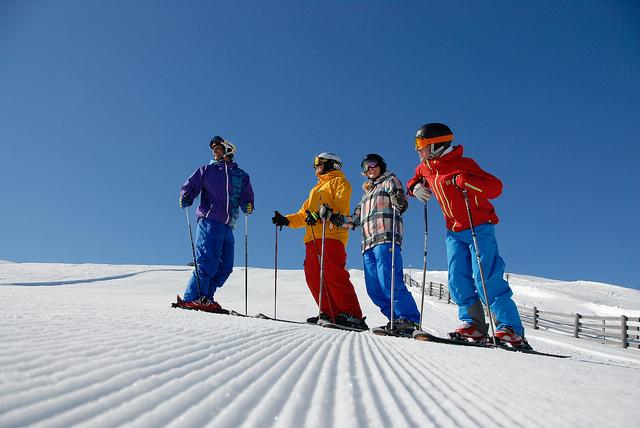Is this all the same person?
Keep it brief. No. How many people are wearing blue pants?
Be succinct. 3. Does this ski slope need to be groomed?
Quick response, please. No. How many people are in the scene?
Short answer required. 4. 